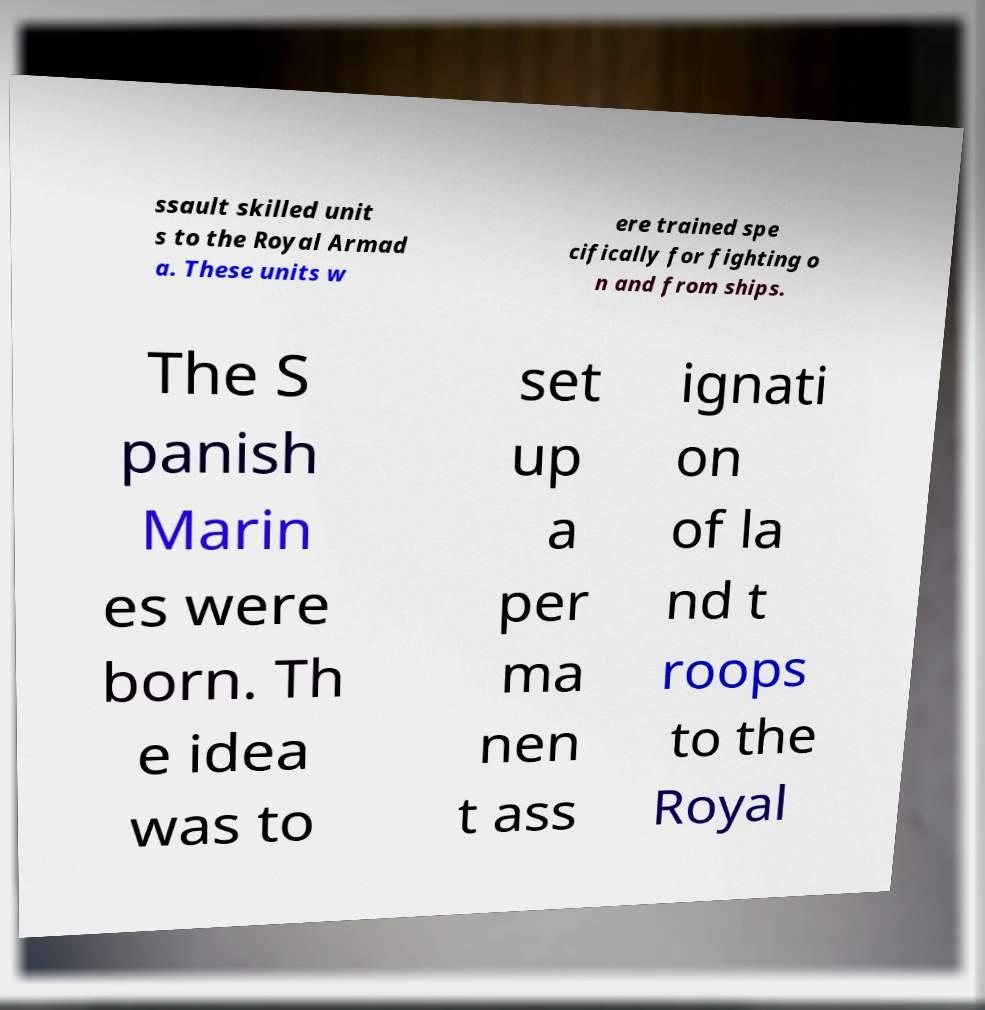Please identify and transcribe the text found in this image. ssault skilled unit s to the Royal Armad a. These units w ere trained spe cifically for fighting o n and from ships. The S panish Marin es were born. Th e idea was to set up a per ma nen t ass ignati on of la nd t roops to the Royal 